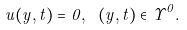Convert formula to latex. <formula><loc_0><loc_0><loc_500><loc_500>u ( y , t ) = 0 , \ ( y , t ) \in \Upsilon ^ { 0 } .</formula> 